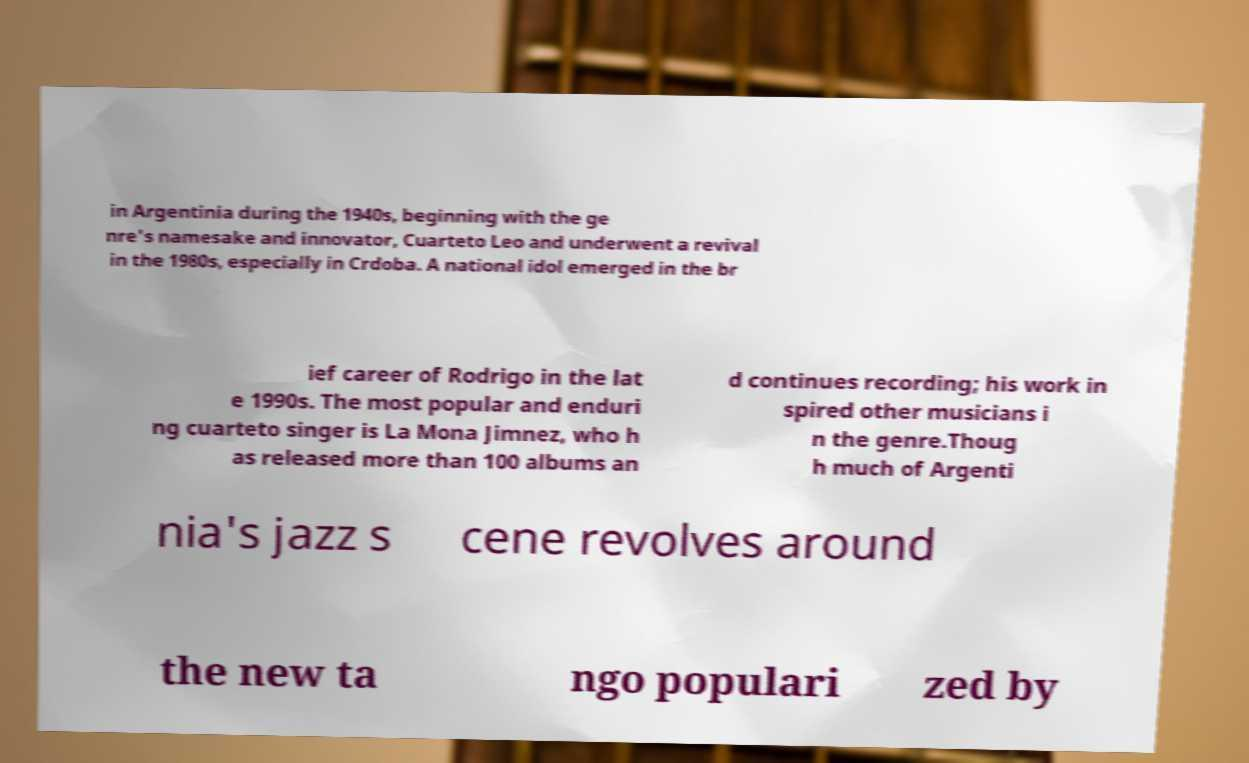Can you accurately transcribe the text from the provided image for me? in Argentinia during the 1940s, beginning with the ge nre's namesake and innovator, Cuarteto Leo and underwent a revival in the 1980s, especially in Crdoba. A national idol emerged in the br ief career of Rodrigo in the lat e 1990s. The most popular and enduri ng cuarteto singer is La Mona Jimnez, who h as released more than 100 albums an d continues recording; his work in spired other musicians i n the genre.Thoug h much of Argenti nia's jazz s cene revolves around the new ta ngo populari zed by 